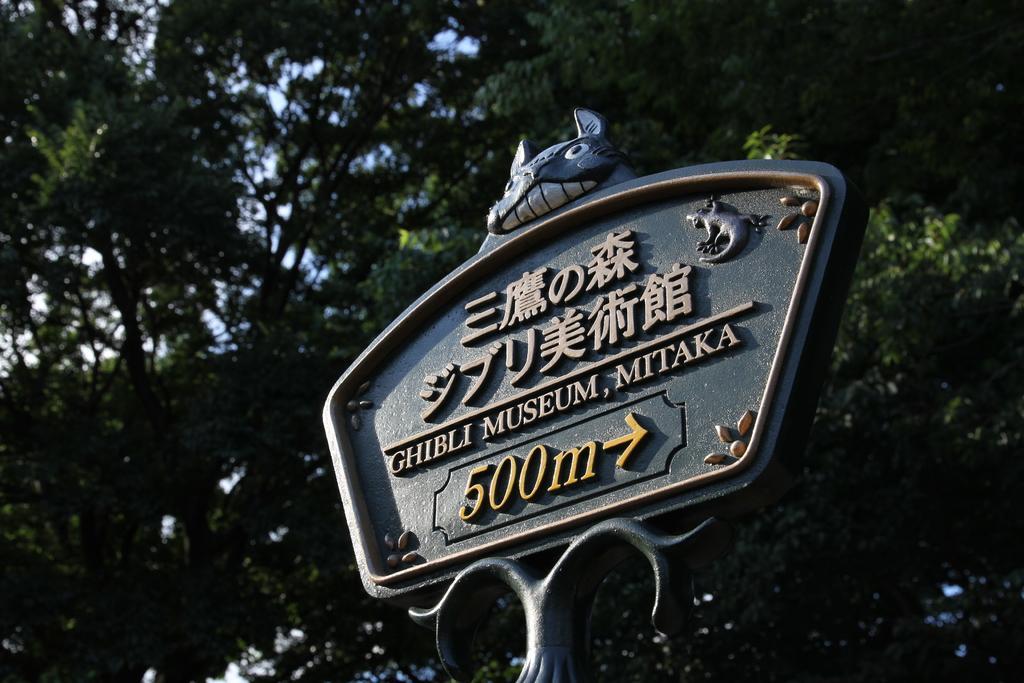How would you summarize this image in a sentence or two? In this image there is a metal structure with some text is on the top of a pole and on the structure there is a depiction of an animal. In the background there are trees. 